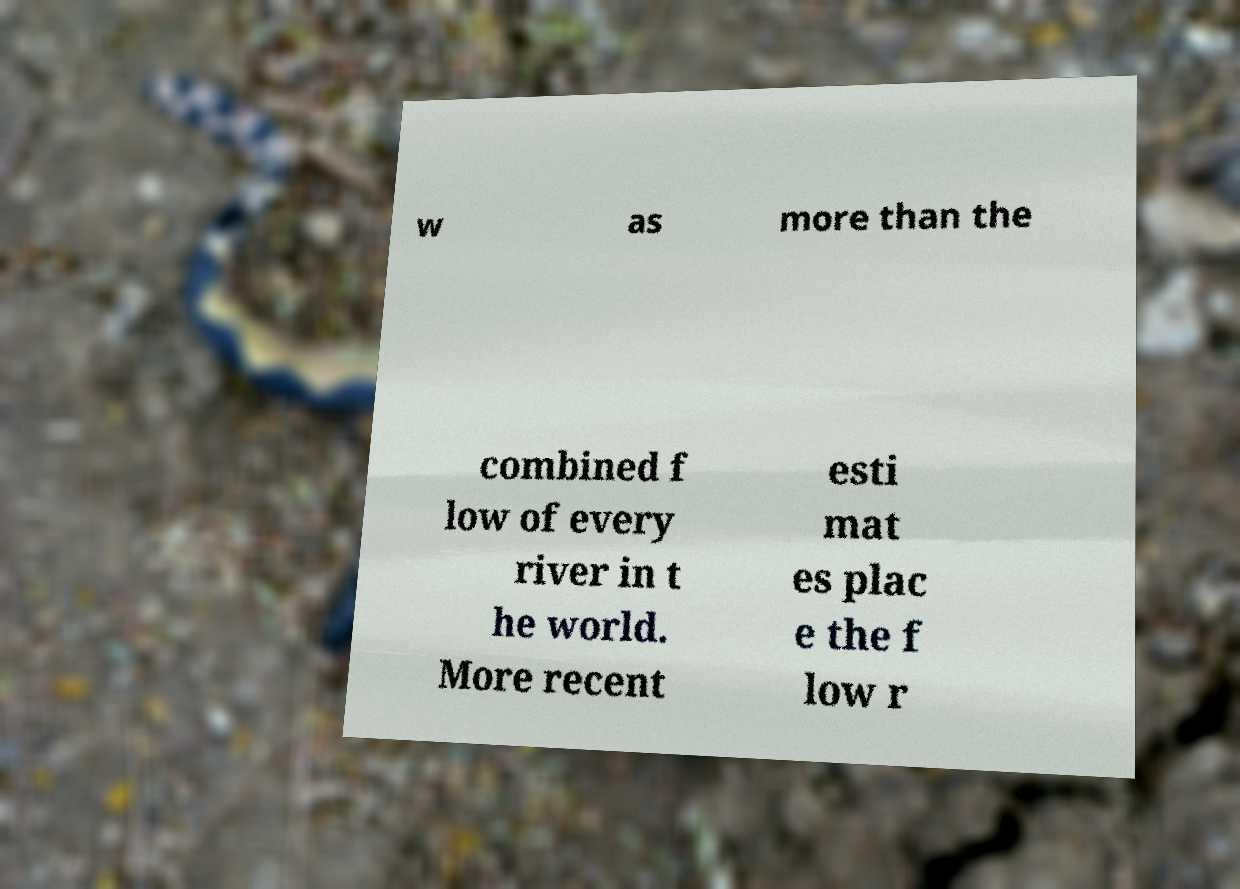For documentation purposes, I need the text within this image transcribed. Could you provide that? w as more than the combined f low of every river in t he world. More recent esti mat es plac e the f low r 